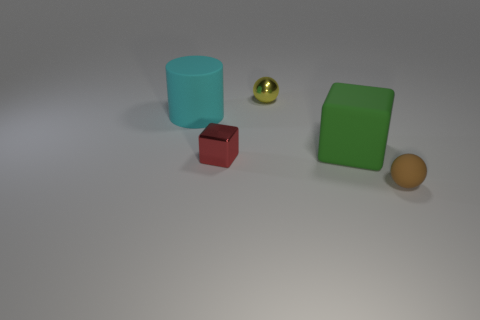How big is the block behind the shiny thing in front of the small shiny sphere?
Your answer should be very brief. Large. Is the number of cyan cylinders to the right of the small matte object the same as the number of red shiny things that are on the left side of the large cyan rubber cylinder?
Provide a succinct answer. Yes. There is a matte object to the left of the tiny red metallic object; is there a rubber thing that is to the left of it?
Make the answer very short. No. There is a tiny thing that is made of the same material as the large cylinder; what is its shape?
Keep it short and to the point. Sphere. Is there any other thing that has the same color as the rubber cylinder?
Offer a very short reply. No. What is the material of the ball to the left of the sphere on the right side of the small yellow ball?
Provide a succinct answer. Metal. Are there any red shiny objects of the same shape as the big cyan matte object?
Offer a very short reply. No. What number of other objects are there of the same shape as the yellow object?
Make the answer very short. 1. What is the shape of the thing that is both behind the green rubber cube and left of the yellow object?
Ensure brevity in your answer.  Cylinder. There is a block that is right of the tiny block; what is its size?
Ensure brevity in your answer.  Large. 